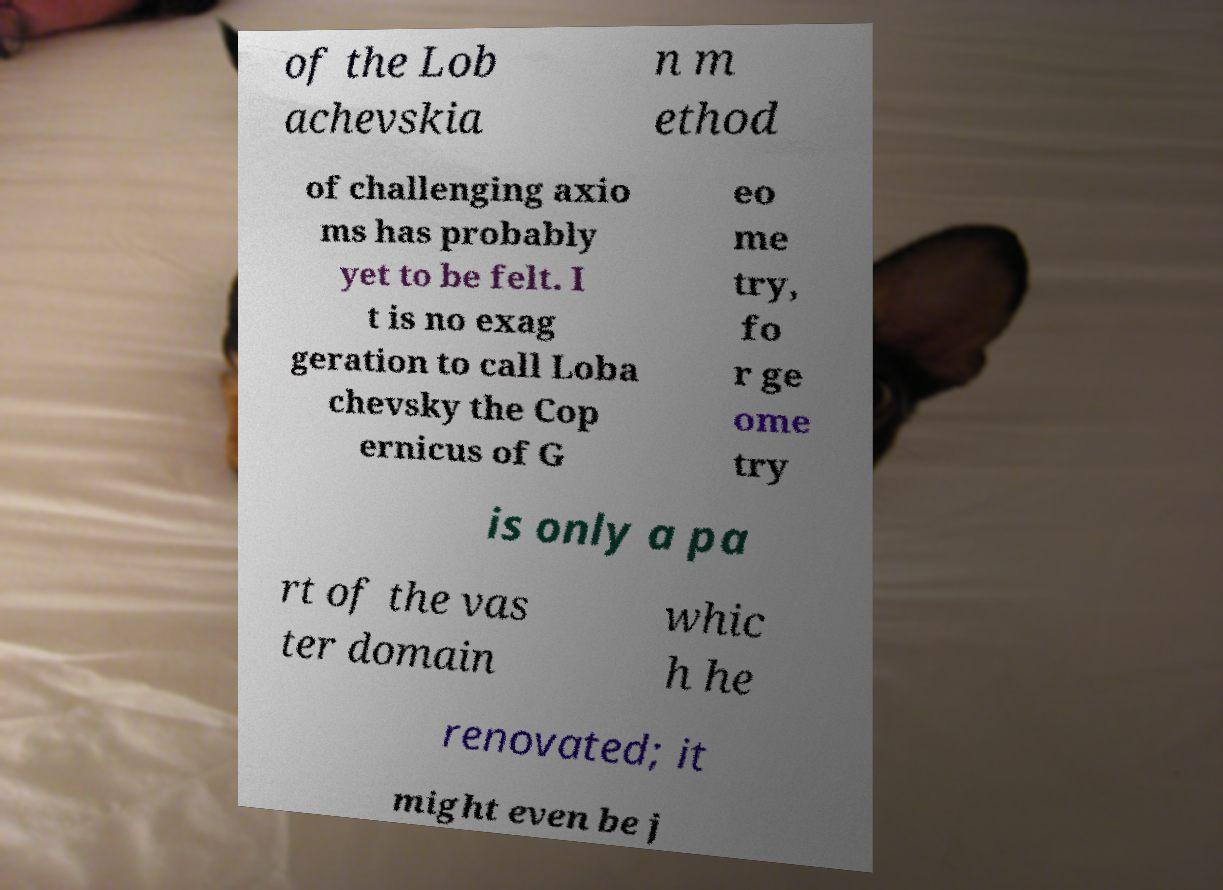Can you accurately transcribe the text from the provided image for me? of the Lob achevskia n m ethod of challenging axio ms has probably yet to be felt. I t is no exag geration to call Loba chevsky the Cop ernicus of G eo me try, fo r ge ome try is only a pa rt of the vas ter domain whic h he renovated; it might even be j 